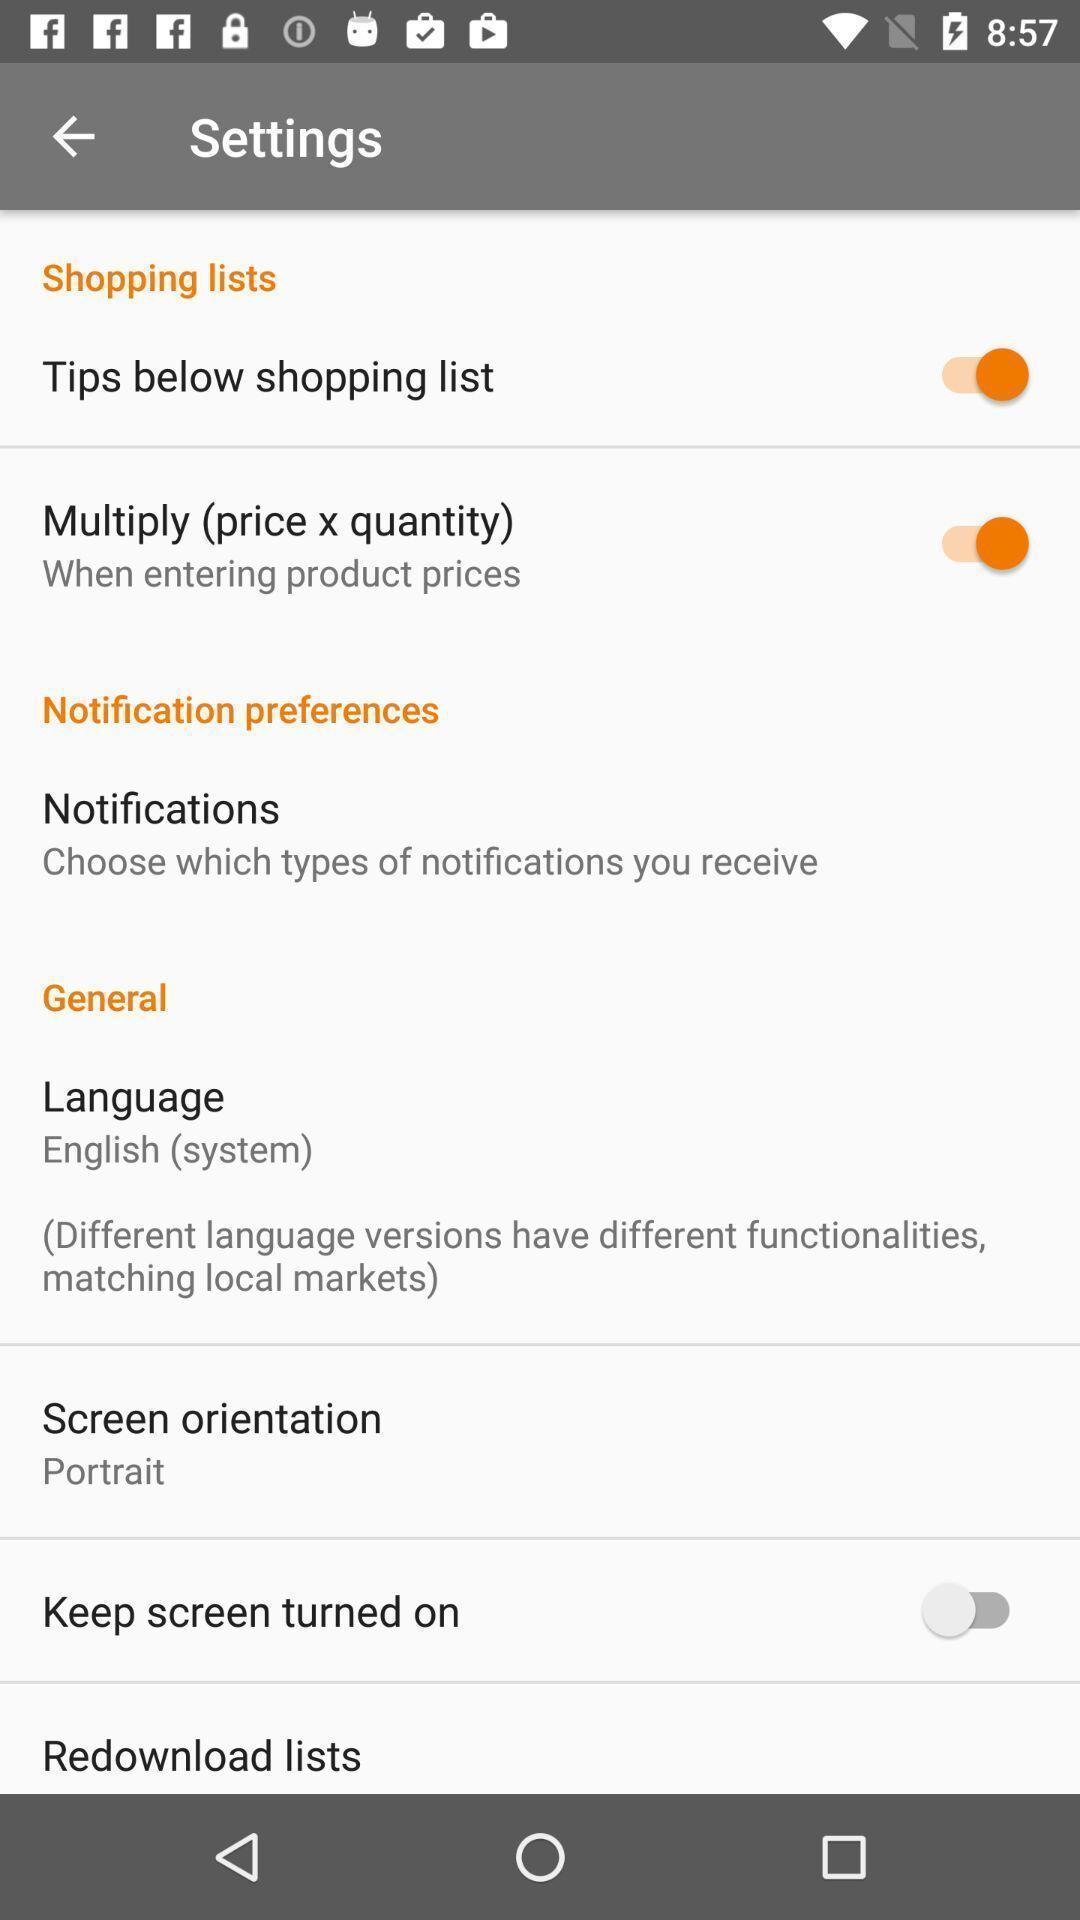Provide a detailed account of this screenshot. Settings tab with different options in the application. 